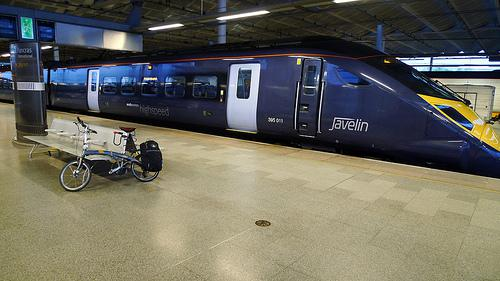Question: who is sitting on the bench?
Choices:
A. No one.
B. My mom.
C. Two men.
D. A child.
Answer with the letter. Answer: A Question: where is the bike?
Choices:
A. In the bike rack.
B. In the garage.
C. By the car.
D. Beside the bench.
Answer with the letter. Answer: D Question: what is the color of the bench?
Choices:
A. Black.
B. White.
C. Brown.
D. Green.
Answer with the letter. Answer: B Question: why the train is parked?
Choices:
A. It had broken down.
B. It is preparing to turn around.
C. It reached its station.
D. It is waiting for passengers.
Answer with the letter. Answer: C Question: how is the bike parked?
Choices:
A. Laying on the ground.
B. With the kickstand up.
C. Leaning on the bench.
D. Hanging from the rack.
Answer with the letter. Answer: C Question: what is the color of the front of the train?
Choices:
A. White.
B. Blue.
C. Yellow.
D. Red.
Answer with the letter. Answer: C 